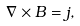<formula> <loc_0><loc_0><loc_500><loc_500>\nabla \times B = j ,</formula> 